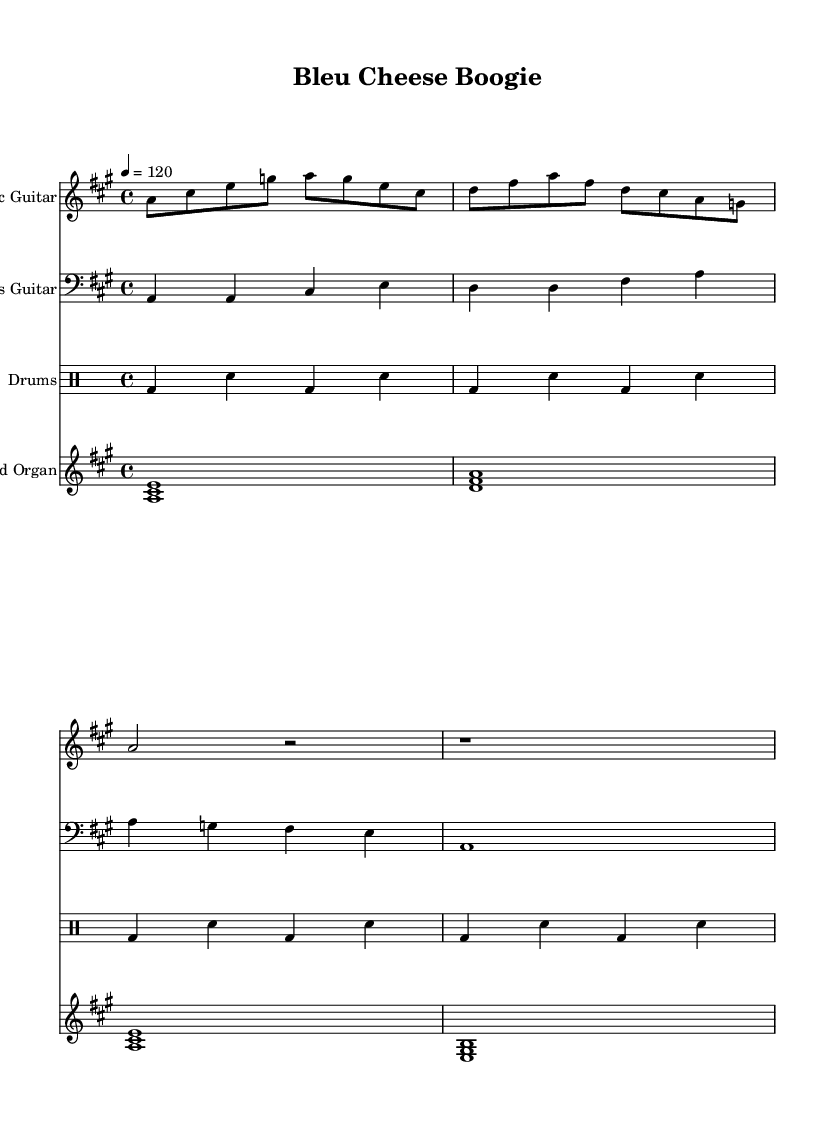What is the key signature of this music? The key signature is indicated at the beginning of the staff, showing one sharp (F#), which defines the piece as being in A major.
Answer: A major What is the time signature? The time signature is located near the beginning of the score and is shown as a fraction: 4 over 4, indicating that there are four beats in each measure.
Answer: 4/4 What is the tempo marking for this piece? The tempo marking appears at the start of the score, stating "4 = 120", which indicates the quarter note equals 120 beats per minute.
Answer: 120 How many measures are in the electric guitar part? Counting the measures shown for the electric guitar, there are four measures provided in total from the score.
Answer: Four What instruments are featured in this piece? The score lists multiple instruments: Electric Guitar, Bass Guitar, Drums, and Hammond Organ, which are all present in the score.
Answer: Electric Guitar, Bass Guitar, Drums, Hammond Organ What type of chord is played on the organ in the first measure? The organ plays an A major chord in the first measure, as it consists of the notes A, C#, and E which are the root, third, and fifth of the A major scale.
Answer: A major What is the main theme communicated in the lyrics? The lyrics suggest a narrative about cheese making, especially focusing on the process of stirring curds and aging cheese, creatively linking it to the music's fun and funky nature.
Answer: Cheese making 